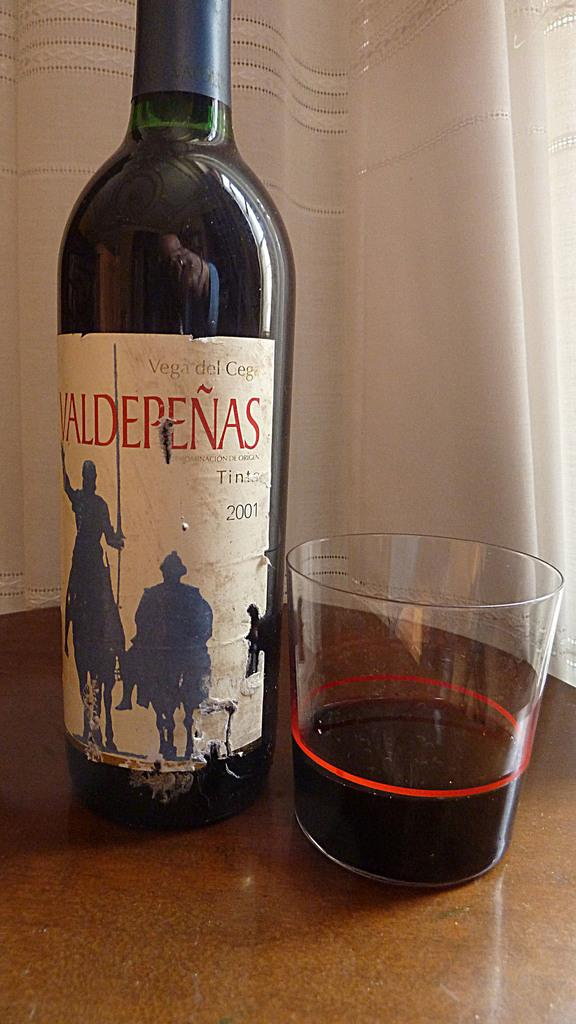<image>
Summarize the visual content of the image. A bottle of Valdepenas wine is on a table next to a glass. 